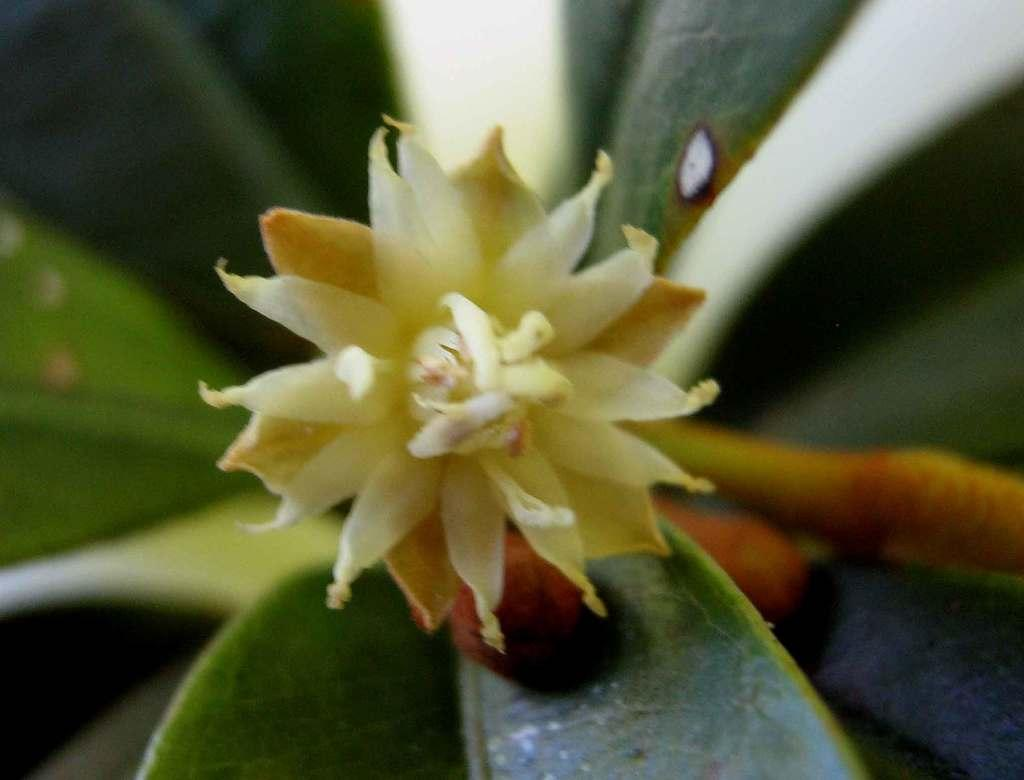What type of plant is visible in the image? There is a flower in the image. What else can be seen in the image besides the flower? There are leaves in the image. What type of argument is taking place between the leaves in the image? There is no argument taking place between the leaves in the image, as leaves do not engage in arguments. 